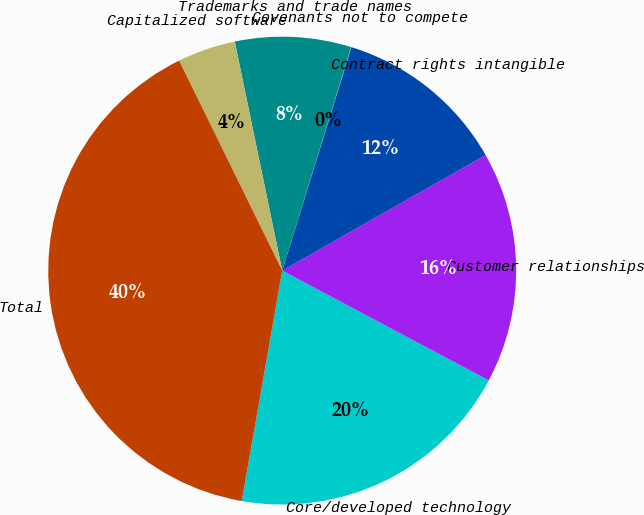<chart> <loc_0><loc_0><loc_500><loc_500><pie_chart><fcel>Core/developed technology<fcel>Customer relationships<fcel>Contract rights intangible<fcel>Covenants not to compete<fcel>Trademarks and trade names<fcel>Capitalized software<fcel>Total<nl><fcel>19.99%<fcel>16.0%<fcel>12.0%<fcel>0.02%<fcel>8.01%<fcel>4.01%<fcel>39.97%<nl></chart> 